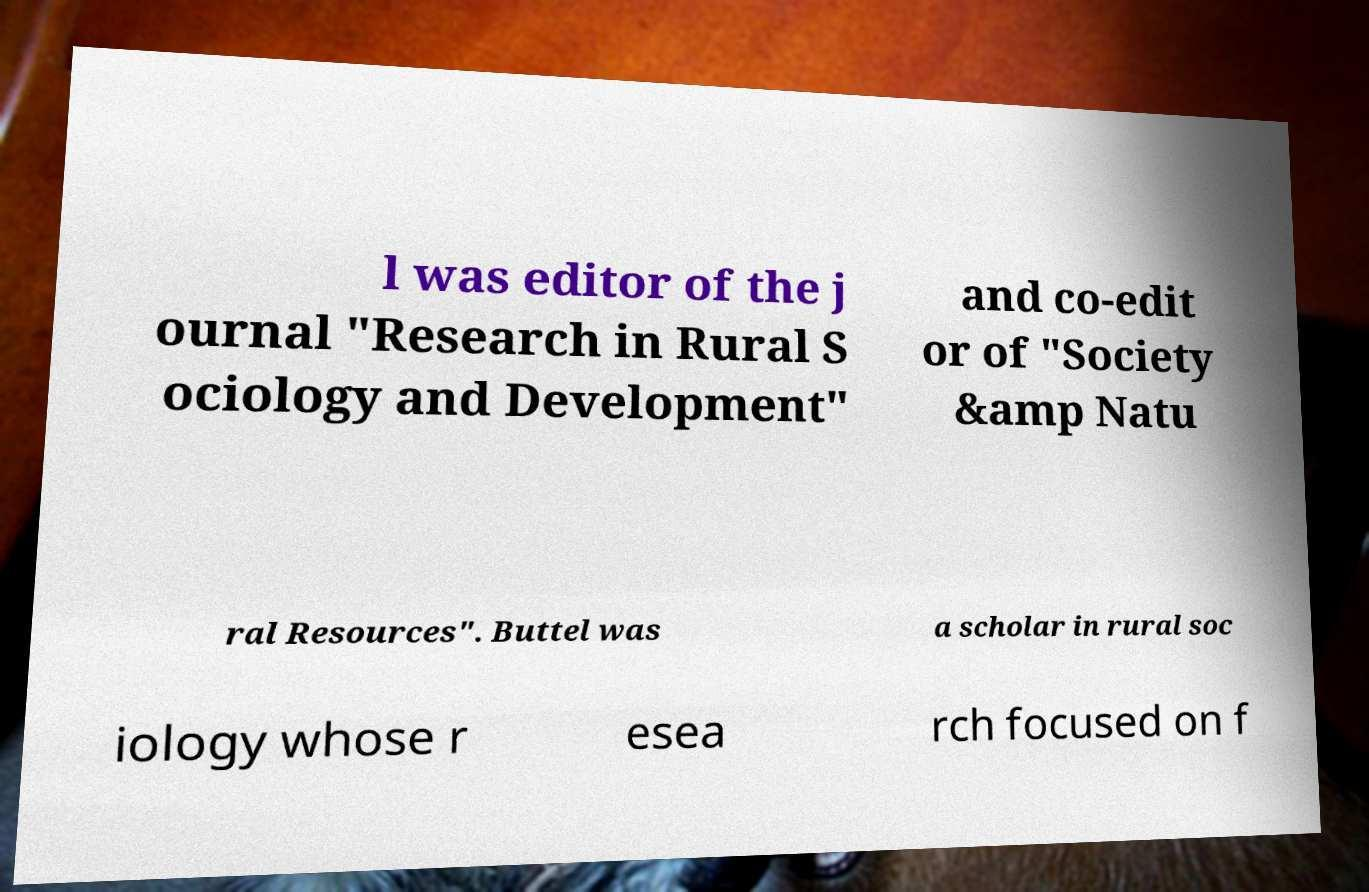Could you extract and type out the text from this image? l was editor of the j ournal "Research in Rural S ociology and Development" and co-edit or of "Society &amp Natu ral Resources". Buttel was a scholar in rural soc iology whose r esea rch focused on f 